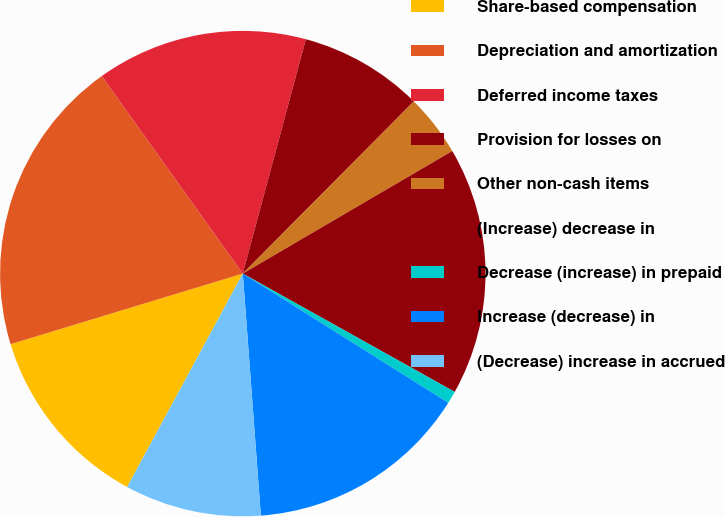Convert chart. <chart><loc_0><loc_0><loc_500><loc_500><pie_chart><fcel>Share-based compensation<fcel>Depreciation and amortization<fcel>Deferred income taxes<fcel>Provision for losses on<fcel>Other non-cash items<fcel>(Increase) decrease in<fcel>Decrease (increase) in prepaid<fcel>Increase (decrease) in<fcel>(Decrease) increase in accrued<nl><fcel>12.4%<fcel>19.83%<fcel>14.05%<fcel>8.26%<fcel>4.13%<fcel>16.53%<fcel>0.83%<fcel>14.88%<fcel>9.09%<nl></chart> 